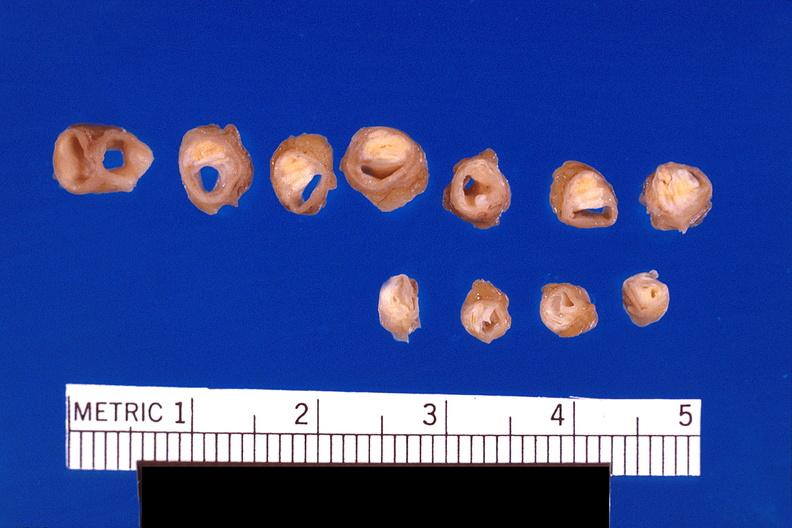does this image show atherosclerosis?
Answer the question using a single word or phrase. Yes 